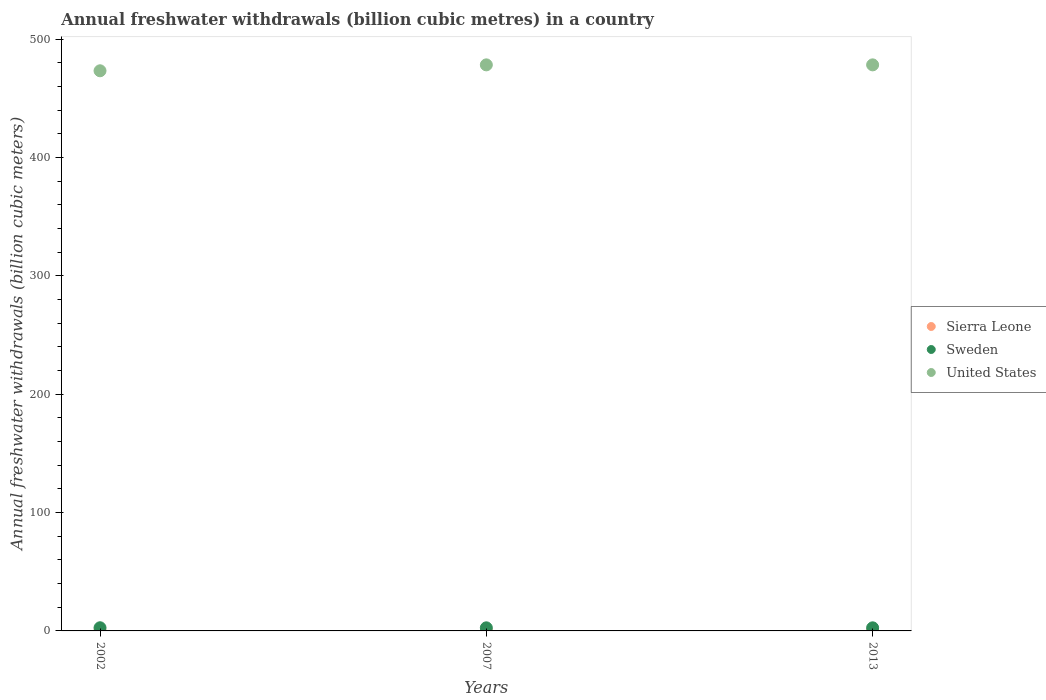Is the number of dotlines equal to the number of legend labels?
Ensure brevity in your answer.  Yes. What is the annual freshwater withdrawals in Sierra Leone in 2002?
Keep it short and to the point. 0.19. Across all years, what is the maximum annual freshwater withdrawals in United States?
Ensure brevity in your answer.  478.4. Across all years, what is the minimum annual freshwater withdrawals in Sierra Leone?
Your answer should be very brief. 0.19. In which year was the annual freshwater withdrawals in Sierra Leone minimum?
Provide a short and direct response. 2002. What is the total annual freshwater withdrawals in Sweden in the graph?
Keep it short and to the point. 7.9. What is the difference between the annual freshwater withdrawals in Sweden in 2002 and that in 2007?
Provide a succinct answer. 0.06. What is the difference between the annual freshwater withdrawals in United States in 2002 and the annual freshwater withdrawals in Sierra Leone in 2007?
Offer a terse response. 473.19. What is the average annual freshwater withdrawals in United States per year?
Your answer should be very brief. 476.73. In the year 2007, what is the difference between the annual freshwater withdrawals in Sweden and annual freshwater withdrawals in Sierra Leone?
Your response must be concise. 2.4. In how many years, is the annual freshwater withdrawals in United States greater than 340 billion cubic meters?
Your answer should be compact. 3. What is the ratio of the annual freshwater withdrawals in Sweden in 2002 to that in 2007?
Ensure brevity in your answer.  1.02. Is the difference between the annual freshwater withdrawals in Sweden in 2007 and 2013 greater than the difference between the annual freshwater withdrawals in Sierra Leone in 2007 and 2013?
Your answer should be compact. No. What is the difference between the highest and the second highest annual freshwater withdrawals in Sweden?
Your response must be concise. 0.06. What is the difference between the highest and the lowest annual freshwater withdrawals in Sweden?
Offer a terse response. 0.06. In how many years, is the annual freshwater withdrawals in Sweden greater than the average annual freshwater withdrawals in Sweden taken over all years?
Your response must be concise. 1. Is the sum of the annual freshwater withdrawals in United States in 2002 and 2013 greater than the maximum annual freshwater withdrawals in Sierra Leone across all years?
Provide a short and direct response. Yes. Is it the case that in every year, the sum of the annual freshwater withdrawals in Sweden and annual freshwater withdrawals in Sierra Leone  is greater than the annual freshwater withdrawals in United States?
Make the answer very short. No. Does the annual freshwater withdrawals in Sweden monotonically increase over the years?
Your answer should be very brief. No. Is the annual freshwater withdrawals in Sweden strictly greater than the annual freshwater withdrawals in United States over the years?
Ensure brevity in your answer.  No. Is the annual freshwater withdrawals in United States strictly less than the annual freshwater withdrawals in Sierra Leone over the years?
Your answer should be compact. No. How many dotlines are there?
Offer a very short reply. 3. How many years are there in the graph?
Your answer should be very brief. 3. What is the difference between two consecutive major ticks on the Y-axis?
Your answer should be very brief. 100. Does the graph contain any zero values?
Give a very brief answer. No. Does the graph contain grids?
Ensure brevity in your answer.  No. How many legend labels are there?
Your answer should be very brief. 3. What is the title of the graph?
Give a very brief answer. Annual freshwater withdrawals (billion cubic metres) in a country. What is the label or title of the X-axis?
Your answer should be very brief. Years. What is the label or title of the Y-axis?
Your answer should be very brief. Annual freshwater withdrawals (billion cubic meters). What is the Annual freshwater withdrawals (billion cubic meters) of Sierra Leone in 2002?
Provide a short and direct response. 0.19. What is the Annual freshwater withdrawals (billion cubic meters) of Sweden in 2002?
Keep it short and to the point. 2.67. What is the Annual freshwater withdrawals (billion cubic meters) in United States in 2002?
Ensure brevity in your answer.  473.4. What is the Annual freshwater withdrawals (billion cubic meters) in Sierra Leone in 2007?
Your answer should be very brief. 0.21. What is the Annual freshwater withdrawals (billion cubic meters) in Sweden in 2007?
Ensure brevity in your answer.  2.62. What is the Annual freshwater withdrawals (billion cubic meters) of United States in 2007?
Offer a very short reply. 478.4. What is the Annual freshwater withdrawals (billion cubic meters) of Sierra Leone in 2013?
Your answer should be compact. 0.21. What is the Annual freshwater withdrawals (billion cubic meters) in Sweden in 2013?
Your response must be concise. 2.62. What is the Annual freshwater withdrawals (billion cubic meters) in United States in 2013?
Offer a terse response. 478.4. Across all years, what is the maximum Annual freshwater withdrawals (billion cubic meters) of Sierra Leone?
Give a very brief answer. 0.21. Across all years, what is the maximum Annual freshwater withdrawals (billion cubic meters) of Sweden?
Your response must be concise. 2.67. Across all years, what is the maximum Annual freshwater withdrawals (billion cubic meters) in United States?
Make the answer very short. 478.4. Across all years, what is the minimum Annual freshwater withdrawals (billion cubic meters) in Sierra Leone?
Keep it short and to the point. 0.19. Across all years, what is the minimum Annual freshwater withdrawals (billion cubic meters) of Sweden?
Your answer should be very brief. 2.62. Across all years, what is the minimum Annual freshwater withdrawals (billion cubic meters) of United States?
Your response must be concise. 473.4. What is the total Annual freshwater withdrawals (billion cubic meters) in Sierra Leone in the graph?
Your answer should be very brief. 0.61. What is the total Annual freshwater withdrawals (billion cubic meters) of Sweden in the graph?
Provide a short and direct response. 7.91. What is the total Annual freshwater withdrawals (billion cubic meters) of United States in the graph?
Offer a terse response. 1430.2. What is the difference between the Annual freshwater withdrawals (billion cubic meters) of Sierra Leone in 2002 and that in 2007?
Give a very brief answer. -0.02. What is the difference between the Annual freshwater withdrawals (billion cubic meters) in Sweden in 2002 and that in 2007?
Provide a succinct answer. 0.06. What is the difference between the Annual freshwater withdrawals (billion cubic meters) of United States in 2002 and that in 2007?
Your response must be concise. -5. What is the difference between the Annual freshwater withdrawals (billion cubic meters) of Sierra Leone in 2002 and that in 2013?
Provide a succinct answer. -0.02. What is the difference between the Annual freshwater withdrawals (billion cubic meters) of Sweden in 2002 and that in 2013?
Provide a short and direct response. 0.06. What is the difference between the Annual freshwater withdrawals (billion cubic meters) of United States in 2002 and that in 2013?
Your answer should be very brief. -5. What is the difference between the Annual freshwater withdrawals (billion cubic meters) of Sierra Leone in 2007 and that in 2013?
Provide a short and direct response. 0. What is the difference between the Annual freshwater withdrawals (billion cubic meters) in Sweden in 2007 and that in 2013?
Keep it short and to the point. 0. What is the difference between the Annual freshwater withdrawals (billion cubic meters) in Sierra Leone in 2002 and the Annual freshwater withdrawals (billion cubic meters) in Sweden in 2007?
Your answer should be compact. -2.43. What is the difference between the Annual freshwater withdrawals (billion cubic meters) in Sierra Leone in 2002 and the Annual freshwater withdrawals (billion cubic meters) in United States in 2007?
Your response must be concise. -478.21. What is the difference between the Annual freshwater withdrawals (billion cubic meters) in Sweden in 2002 and the Annual freshwater withdrawals (billion cubic meters) in United States in 2007?
Ensure brevity in your answer.  -475.73. What is the difference between the Annual freshwater withdrawals (billion cubic meters) in Sierra Leone in 2002 and the Annual freshwater withdrawals (billion cubic meters) in Sweden in 2013?
Provide a succinct answer. -2.43. What is the difference between the Annual freshwater withdrawals (billion cubic meters) of Sierra Leone in 2002 and the Annual freshwater withdrawals (billion cubic meters) of United States in 2013?
Offer a terse response. -478.21. What is the difference between the Annual freshwater withdrawals (billion cubic meters) of Sweden in 2002 and the Annual freshwater withdrawals (billion cubic meters) of United States in 2013?
Your answer should be very brief. -475.73. What is the difference between the Annual freshwater withdrawals (billion cubic meters) in Sierra Leone in 2007 and the Annual freshwater withdrawals (billion cubic meters) in Sweden in 2013?
Make the answer very short. -2.4. What is the difference between the Annual freshwater withdrawals (billion cubic meters) of Sierra Leone in 2007 and the Annual freshwater withdrawals (billion cubic meters) of United States in 2013?
Provide a succinct answer. -478.19. What is the difference between the Annual freshwater withdrawals (billion cubic meters) of Sweden in 2007 and the Annual freshwater withdrawals (billion cubic meters) of United States in 2013?
Your answer should be very brief. -475.78. What is the average Annual freshwater withdrawals (billion cubic meters) in Sierra Leone per year?
Provide a succinct answer. 0.2. What is the average Annual freshwater withdrawals (billion cubic meters) of Sweden per year?
Give a very brief answer. 2.63. What is the average Annual freshwater withdrawals (billion cubic meters) in United States per year?
Ensure brevity in your answer.  476.73. In the year 2002, what is the difference between the Annual freshwater withdrawals (billion cubic meters) in Sierra Leone and Annual freshwater withdrawals (billion cubic meters) in Sweden?
Make the answer very short. -2.48. In the year 2002, what is the difference between the Annual freshwater withdrawals (billion cubic meters) of Sierra Leone and Annual freshwater withdrawals (billion cubic meters) of United States?
Your response must be concise. -473.21. In the year 2002, what is the difference between the Annual freshwater withdrawals (billion cubic meters) in Sweden and Annual freshwater withdrawals (billion cubic meters) in United States?
Make the answer very short. -470.73. In the year 2007, what is the difference between the Annual freshwater withdrawals (billion cubic meters) in Sierra Leone and Annual freshwater withdrawals (billion cubic meters) in Sweden?
Your answer should be compact. -2.4. In the year 2007, what is the difference between the Annual freshwater withdrawals (billion cubic meters) of Sierra Leone and Annual freshwater withdrawals (billion cubic meters) of United States?
Offer a terse response. -478.19. In the year 2007, what is the difference between the Annual freshwater withdrawals (billion cubic meters) of Sweden and Annual freshwater withdrawals (billion cubic meters) of United States?
Provide a succinct answer. -475.78. In the year 2013, what is the difference between the Annual freshwater withdrawals (billion cubic meters) of Sierra Leone and Annual freshwater withdrawals (billion cubic meters) of Sweden?
Your response must be concise. -2.4. In the year 2013, what is the difference between the Annual freshwater withdrawals (billion cubic meters) in Sierra Leone and Annual freshwater withdrawals (billion cubic meters) in United States?
Your response must be concise. -478.19. In the year 2013, what is the difference between the Annual freshwater withdrawals (billion cubic meters) in Sweden and Annual freshwater withdrawals (billion cubic meters) in United States?
Offer a terse response. -475.78. What is the ratio of the Annual freshwater withdrawals (billion cubic meters) in Sierra Leone in 2002 to that in 2007?
Your response must be concise. 0.89. What is the ratio of the Annual freshwater withdrawals (billion cubic meters) of Sweden in 2002 to that in 2007?
Your answer should be very brief. 1.02. What is the ratio of the Annual freshwater withdrawals (billion cubic meters) in United States in 2002 to that in 2007?
Keep it short and to the point. 0.99. What is the ratio of the Annual freshwater withdrawals (billion cubic meters) of Sierra Leone in 2002 to that in 2013?
Give a very brief answer. 0.89. What is the ratio of the Annual freshwater withdrawals (billion cubic meters) in Sweden in 2002 to that in 2013?
Make the answer very short. 1.02. What is the ratio of the Annual freshwater withdrawals (billion cubic meters) of United States in 2002 to that in 2013?
Your answer should be very brief. 0.99. What is the difference between the highest and the second highest Annual freshwater withdrawals (billion cubic meters) of Sweden?
Offer a terse response. 0.06. What is the difference between the highest and the lowest Annual freshwater withdrawals (billion cubic meters) of Sierra Leone?
Your answer should be very brief. 0.02. What is the difference between the highest and the lowest Annual freshwater withdrawals (billion cubic meters) of Sweden?
Offer a very short reply. 0.06. 